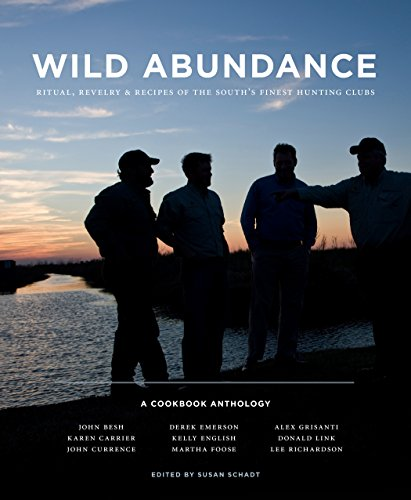Is this a recipe book? Yes, this is primarily a recipe book, focusing on sharing diverse and delectable dishes from various prestigious hunting clubs in the Southern United States, interlaced with stories of community and tradition. 